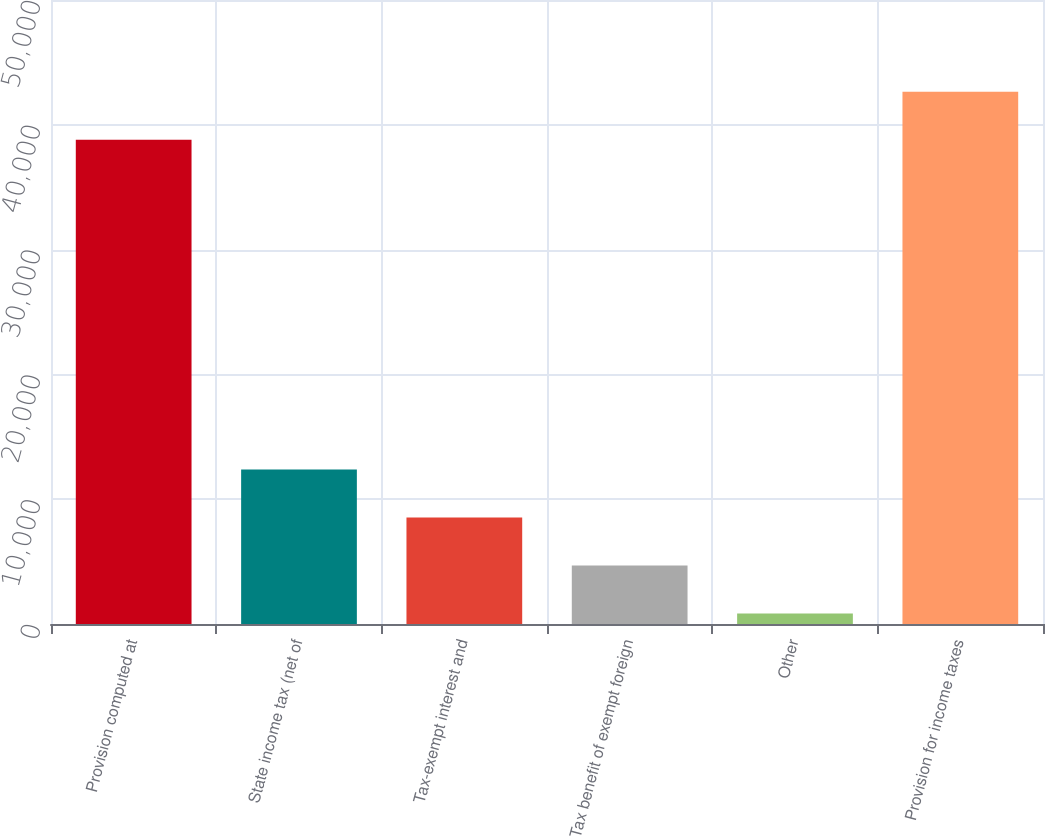<chart> <loc_0><loc_0><loc_500><loc_500><bar_chart><fcel>Provision computed at<fcel>State income tax (net of<fcel>Tax-exempt interest and<fcel>Tax benefit of exempt foreign<fcel>Other<fcel>Provision for income taxes<nl><fcel>38809<fcel>12375.8<fcel>8531.2<fcel>4686.6<fcel>842<fcel>42653.6<nl></chart> 